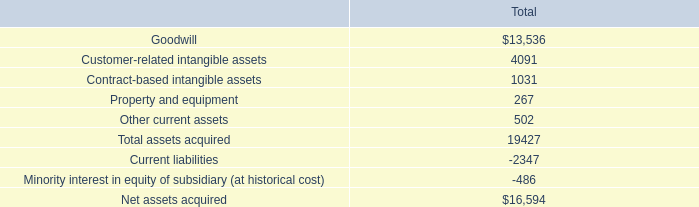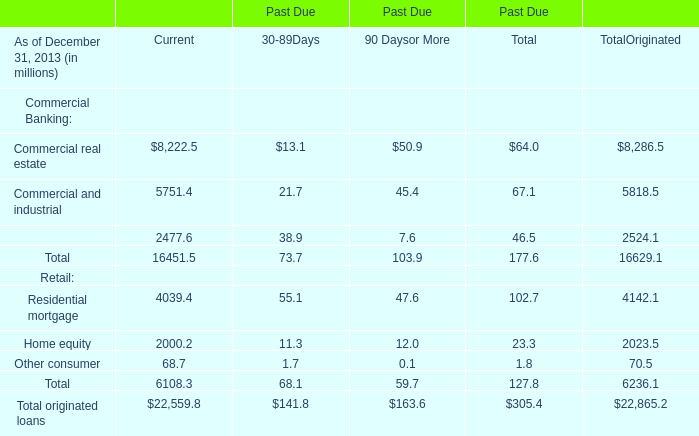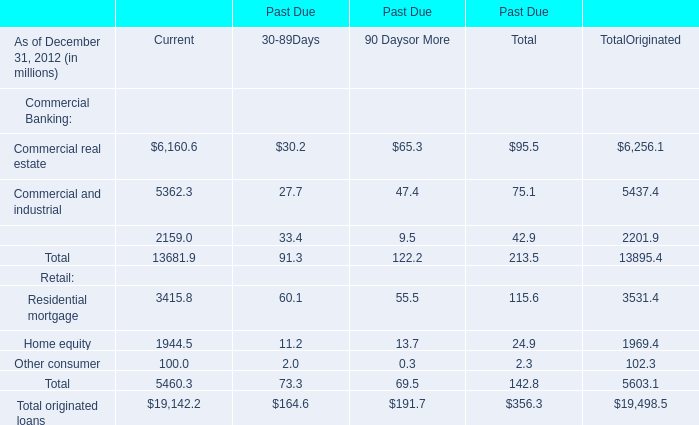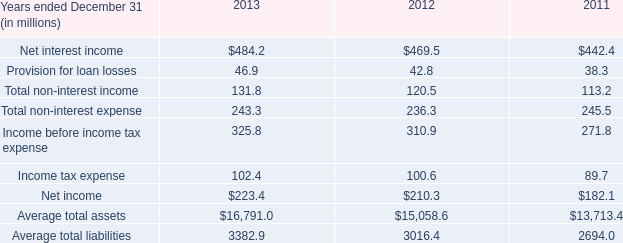What is the sum of 90 Daysor More in the range of 0 and 10 in 2013? (in million) 
Computations: (7.6 + 0.1)
Answer: 7.7. 